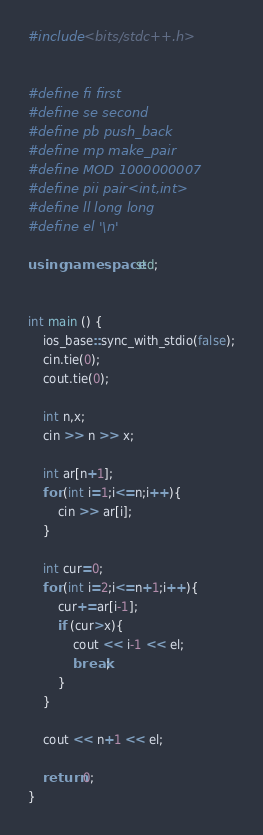Convert code to text. <code><loc_0><loc_0><loc_500><loc_500><_C++_>#include <bits/stdc++.h>


#define fi first
#define se second
#define pb push_back
#define mp make_pair
#define MOD 1000000007
#define pii pair<int,int>
#define ll long long
#define el '\n'

using namespace std;


int main () {
    ios_base::sync_with_stdio(false);
    cin.tie(0);
    cout.tie(0);

    int n,x;
    cin >> n >> x;

    int ar[n+1];
    for (int i=1;i<=n;i++){
        cin >> ar[i];
    }

    int cur=0;
    for (int i=2;i<=n+1;i++){
        cur+=ar[i-1];
        if (cur>x){
            cout << i-1 << el;
            break;
        }
    }

    cout << n+1 << el;

    return 0;
}</code> 